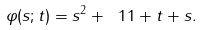<formula> <loc_0><loc_0><loc_500><loc_500>\varphi ( s ; t ) = s ^ { 2 } + \ 1 { 1 + t + s } .</formula> 